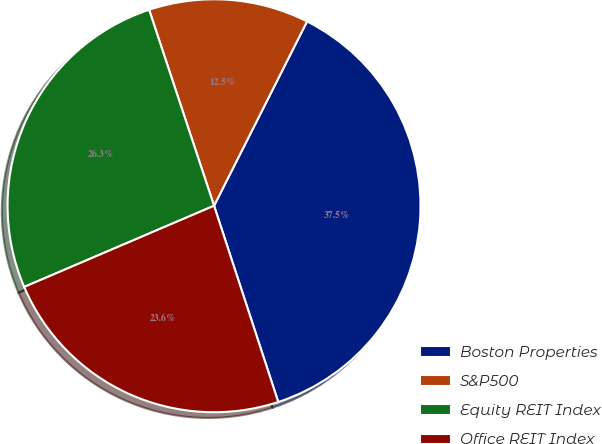Convert chart to OTSL. <chart><loc_0><loc_0><loc_500><loc_500><pie_chart><fcel>Boston Properties<fcel>S&P500<fcel>Equity REIT Index<fcel>Office REIT Index<nl><fcel>37.53%<fcel>12.53%<fcel>26.34%<fcel>23.6%<nl></chart> 